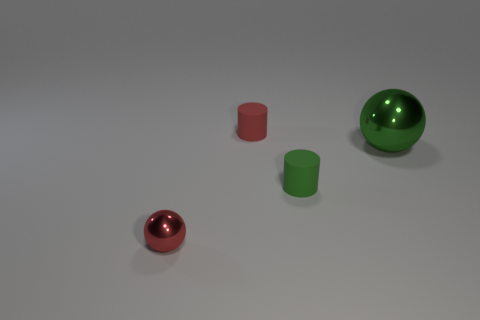Add 1 tiny cyan blocks. How many objects exist? 5 Add 1 red shiny balls. How many red shiny balls are left? 2 Add 3 small green rubber objects. How many small green rubber objects exist? 4 Subtract 0 purple cubes. How many objects are left? 4 Subtract all yellow balls. Subtract all brown blocks. How many balls are left? 2 Subtract all green matte things. Subtract all big things. How many objects are left? 2 